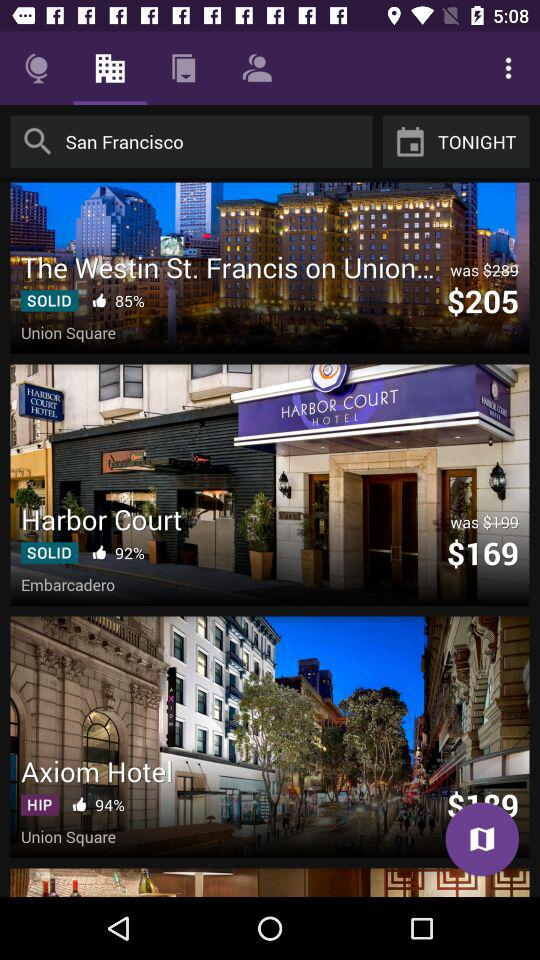What was the actual price of the "Harbor Court"? The actual price of the "Harbor Court" was $199. 